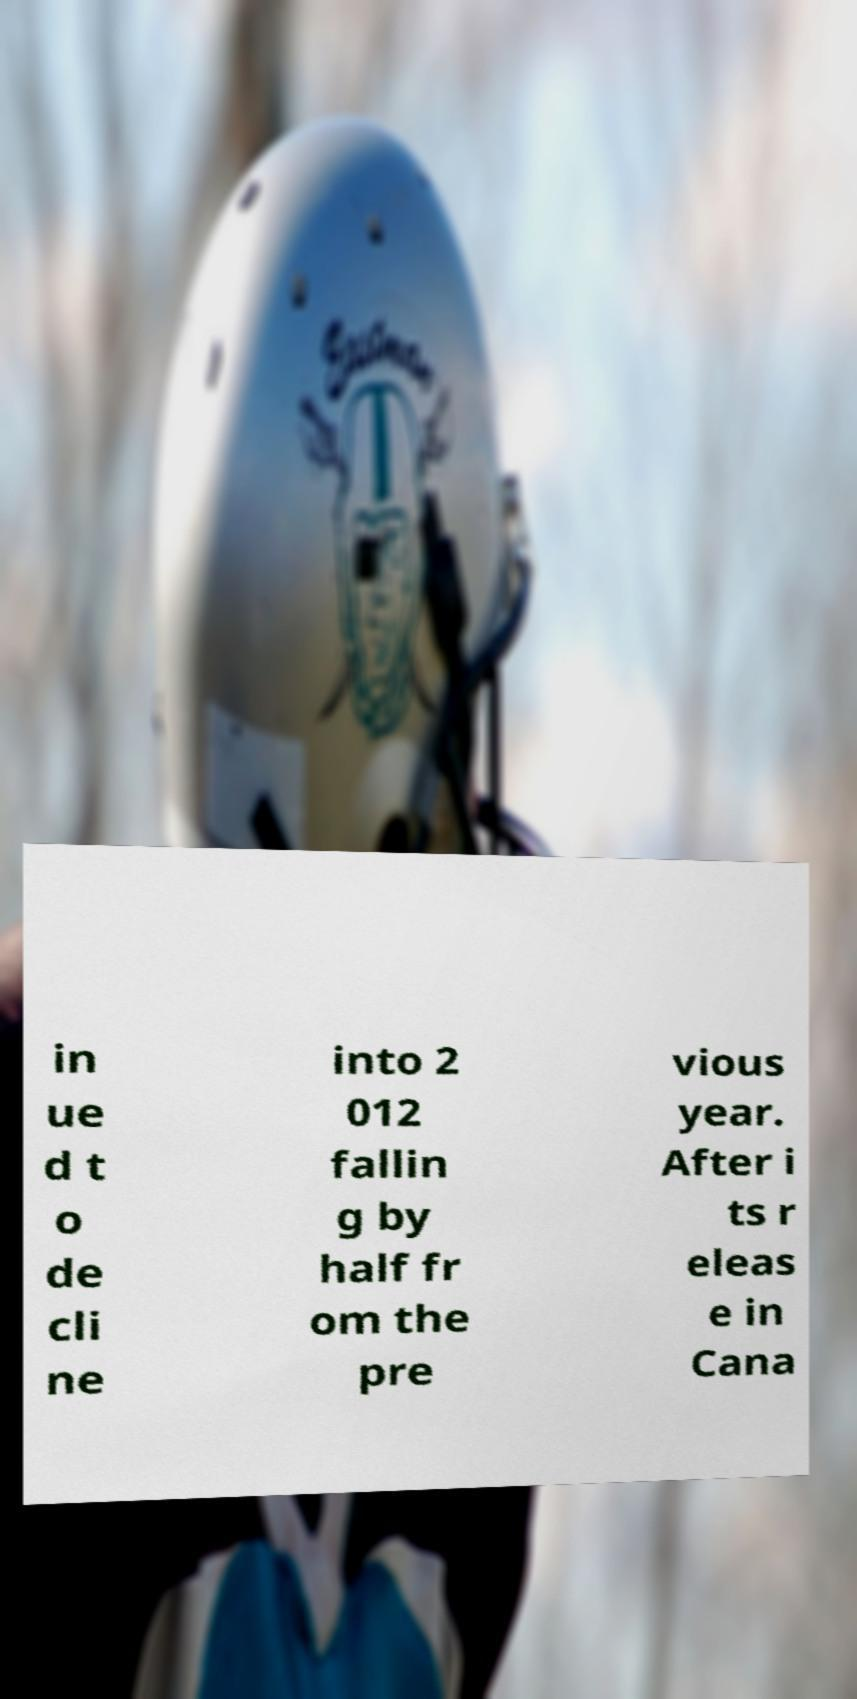Please read and relay the text visible in this image. What does it say? in ue d t o de cli ne into 2 012 fallin g by half fr om the pre vious year. After i ts r eleas e in Cana 